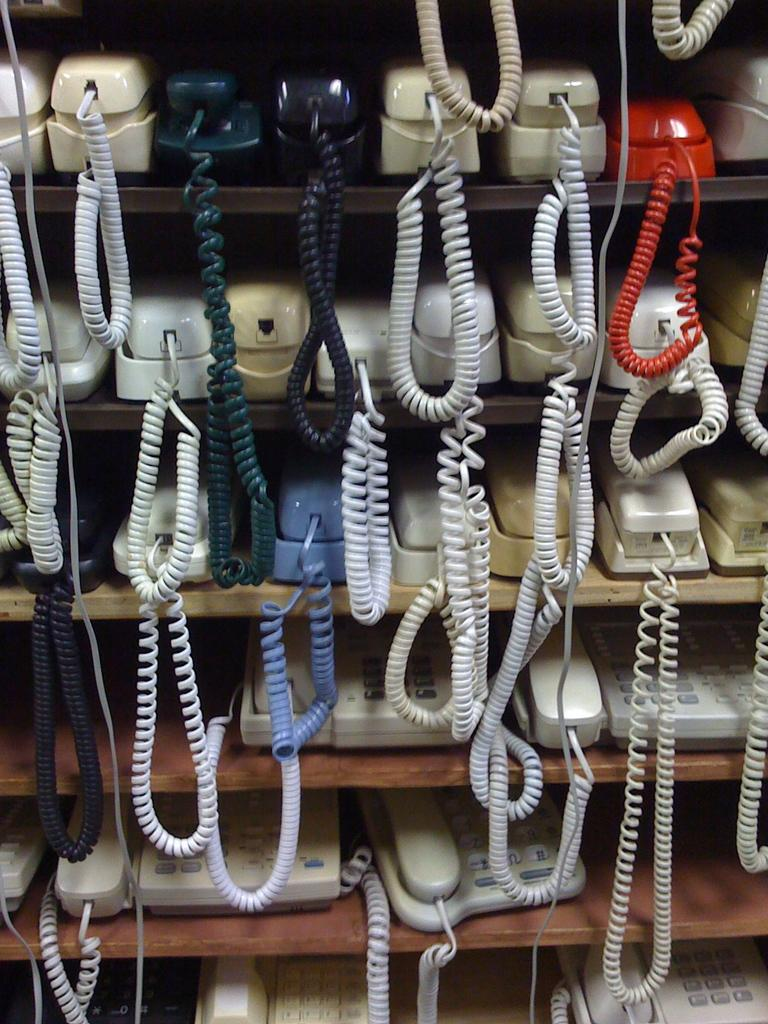What objects are present in the image? There are many cellphones in the image. Where are the cellphones located? The cellphones are inside a cupboard. What can be said about the colors of the cellphones? The cellphones are in various colors, including cream, black, green, white, red, and blue. What is the weight of the net in the image? There is no net present in the image, so it is not possible to determine its weight. 